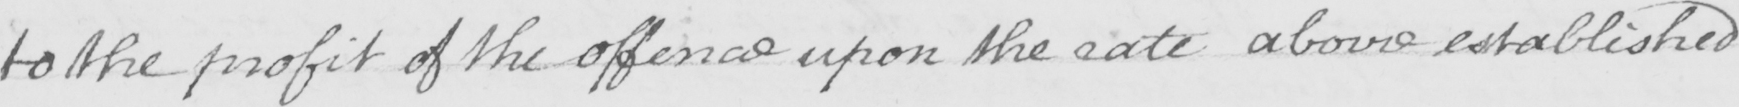What does this handwritten line say? to the profit of the offence upon the rate above established 